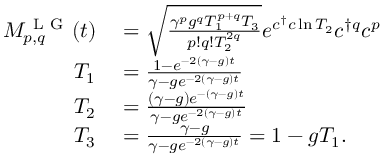Convert formula to latex. <formula><loc_0><loc_0><loc_500><loc_500>\begin{array} { r l } { M _ { p , q } ^ { L G } ( t ) } & = \sqrt { \frac { \gamma ^ { p } g ^ { q } T _ { 1 } ^ { p + q } T _ { 3 } } { p ! q ! T _ { 2 } ^ { 2 q } } } e ^ { c ^ { \dagger } c \ln T _ { 2 } } c ^ { \dagger q } c ^ { p } } \\ { T _ { 1 } } & = \frac { 1 - e ^ { - 2 ( \gamma - g ) t } } { \gamma - g e ^ { - 2 ( \gamma - g ) t } } } \\ { T _ { 2 } } & = \frac { ( \gamma - g ) e ^ { - ( \gamma - g ) t } } { \gamma - g e ^ { - 2 ( \gamma - g ) t } } } \\ { T _ { 3 } } & = \frac { \gamma - g } { \gamma - g e ^ { - 2 ( \gamma - g ) t } } = 1 - g T _ { 1 } . } \end{array}</formula> 